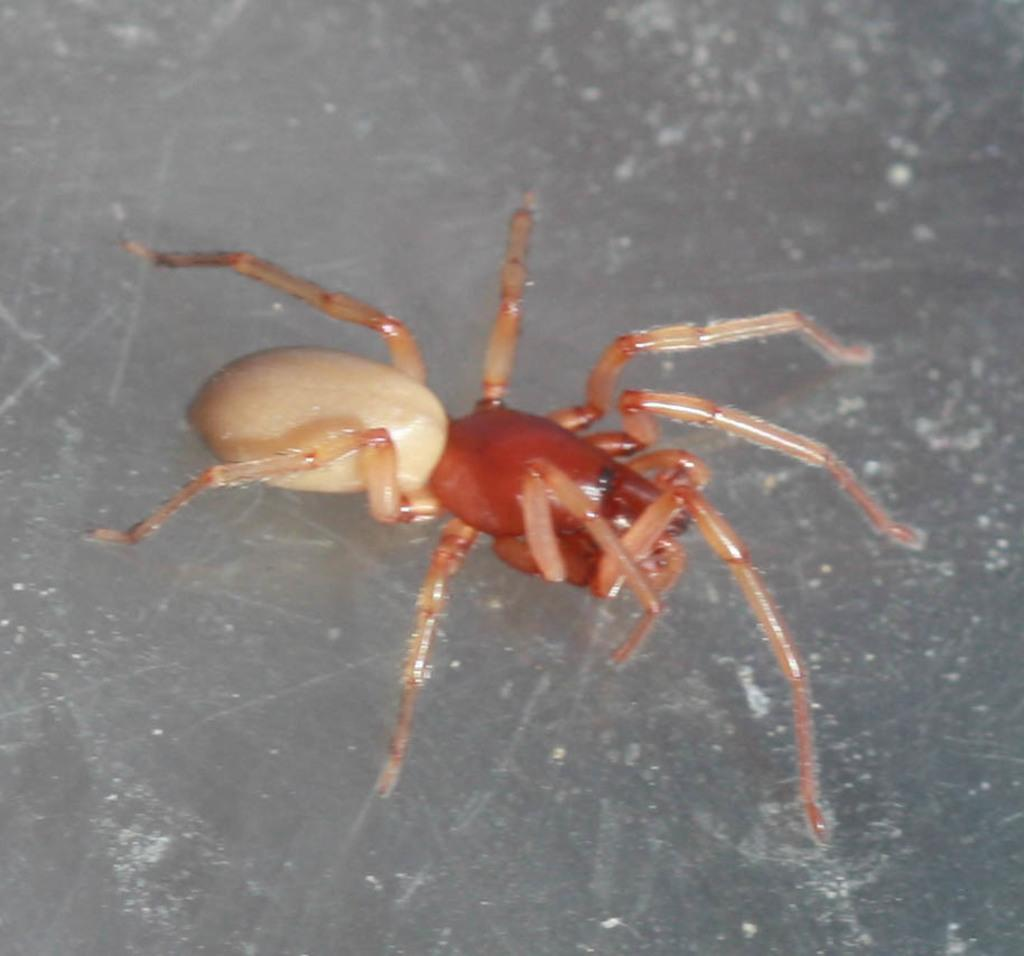What is the main subject of the image? The main subject of the image is a spider. What type of fork is the spider using to eat its meal in the image? There is no fork present in the image, as spiders do not use forks to eat. 